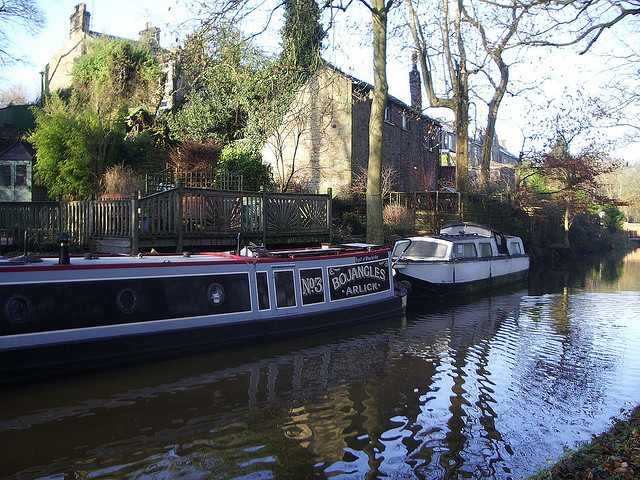Read all the text in this image. arlick No3 BOJANGLES 